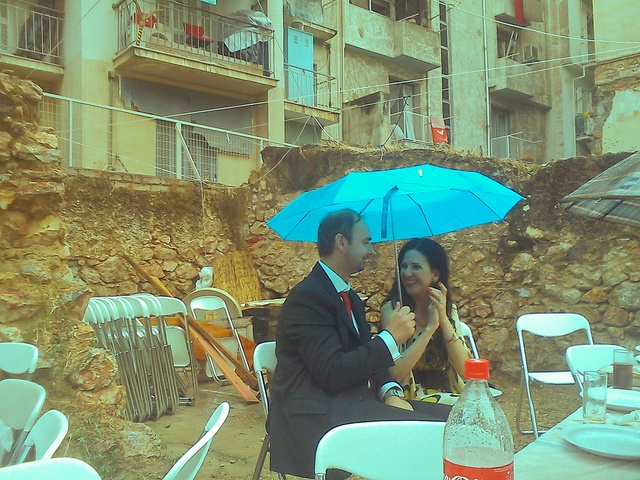Describe the objects in this image and their specific colors. I can see people in olive, gray, black, and purple tones, dining table in olive, turquoise, darkgray, and gray tones, umbrella in olive, cyan, lightblue, gray, and teal tones, people in olive, gray, and black tones, and chair in olive, aquamarine, ivory, and navy tones in this image. 